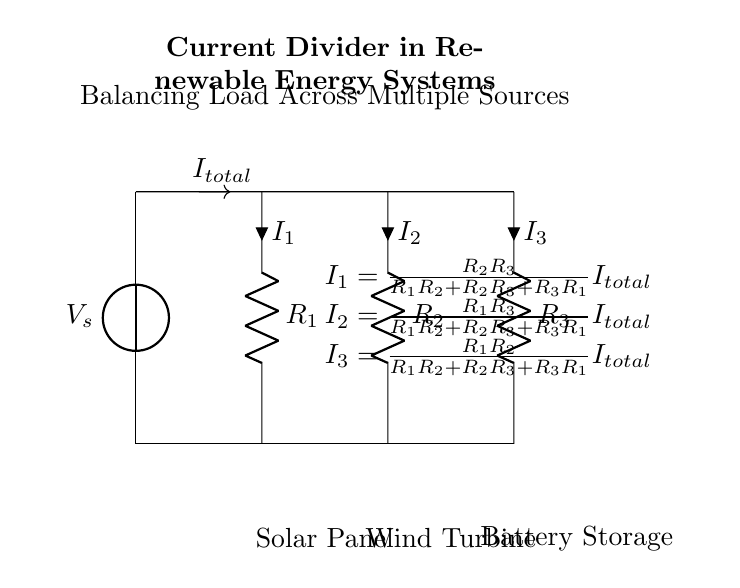What is the total current entering the circuit? The total current entering the circuit is denoted as I_total, which flows from the voltage source into the parallel resistors.
Answer: I_total What components are connected in parallel? The resistors R1, R2, and R3 are connected in parallel configuration as they share the same voltage across their terminals.
Answer: R1, R2, R3 What is the purpose of the current divider in this system? The purpose of the current divider is to split the total current I_total into individual currents I1, I2, and I3 that flow through R1, R2, and R3, respectively, allowing for load balancing among different energy sources.
Answer: Load balancing What is the formula for calculating I1 in this circuit? The formula for calculating I1 is I1 = (R2 * R3) / (R1 * R2 + R2 * R3 + R3 * R1) * I_total, which uses the resistances to determine the proportional current for R1.
Answer: I1 = (R2 * R3) / (R1 * R2 + R2 * R3 + R3 * R1) * I_total How does increasing R2 affect I2? Increasing R2 decreases the value of I2 due to the inverse relationship in the formula I2 = (R1 * R3) / (R1 * R2 + R2 * R3 + R3 * R1) * I_total, as a larger R2 results in a larger denominator, thus reducing I2.
Answer: I2 decreases Which renewable energy sources are represented in the circuit? The renewable energy sources represented in the circuit are a solar panel, a wind turbine, and battery storage, indicated by labels below each component.
Answer: Solar panel, wind turbine, battery storage 